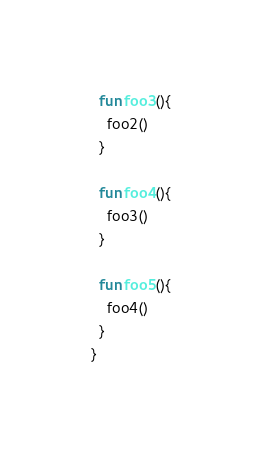Convert code to text. <code><loc_0><loc_0><loc_500><loc_500><_Kotlin_>  fun foo3(){
    foo2()
  }

  fun foo4(){
    foo3()
  }

  fun foo5(){
    foo4()
  }
}</code> 